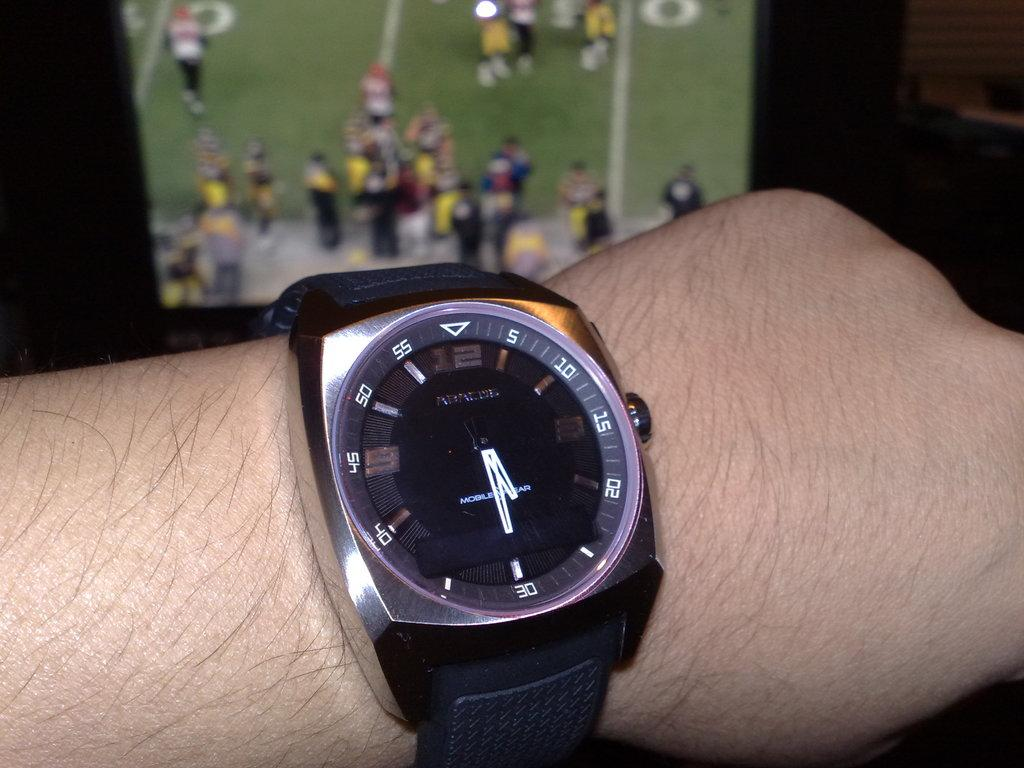<image>
Relay a brief, clear account of the picture shown. Person wearing a wristwatch which says MobileWear on it. 